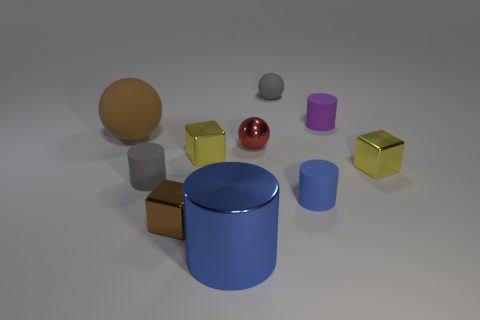What size is the blue cylinder that is made of the same material as the brown block? The blue cylinder appears to be of medium size in comparison to the other objects in the image. It shares a matte surface characteristic with the smaller brown block, indicating they might be made of the same material. 